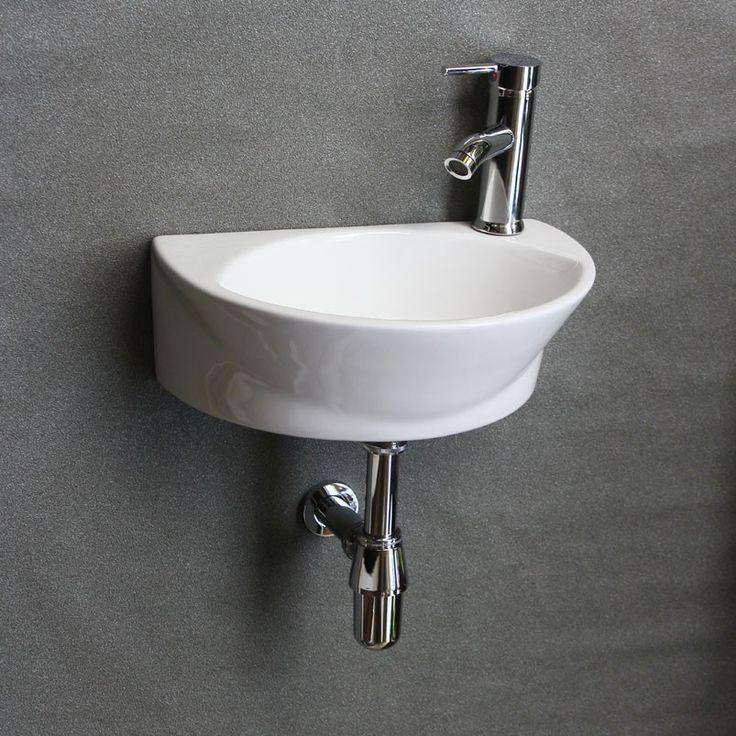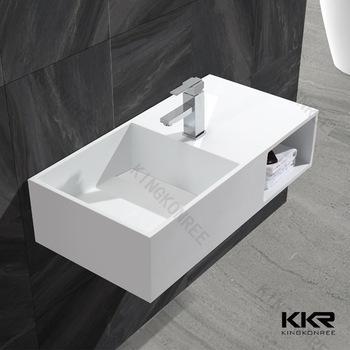The first image is the image on the left, the second image is the image on the right. Considering the images on both sides, is "An image features a wall-mounted semi-circle white sinkwith chrome dispenser on top." valid? Answer yes or no. Yes. The first image is the image on the left, the second image is the image on the right. Assess this claim about the two images: "There is one oval shaped sink and one rectangle shaped sink attached to the wall.". Correct or not? Answer yes or no. Yes. 